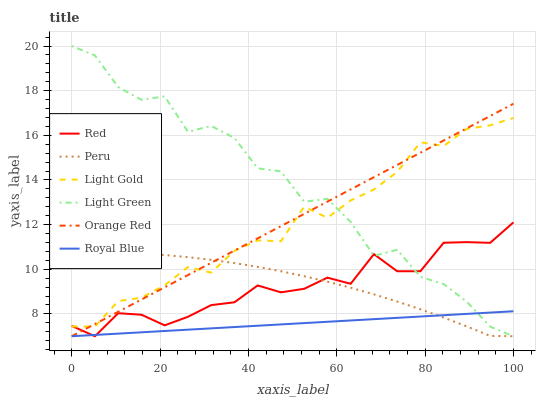Does Royal Blue have the minimum area under the curve?
Answer yes or no. Yes. Does Light Green have the maximum area under the curve?
Answer yes or no. Yes. Does Light Green have the minimum area under the curve?
Answer yes or no. No. Does Royal Blue have the maximum area under the curve?
Answer yes or no. No. Is Royal Blue the smoothest?
Answer yes or no. Yes. Is Light Green the roughest?
Answer yes or no. Yes. Is Light Green the smoothest?
Answer yes or no. No. Is Royal Blue the roughest?
Answer yes or no. No. Does Peru have the lowest value?
Answer yes or no. Yes. Does Light Gold have the lowest value?
Answer yes or no. No. Does Light Green have the highest value?
Answer yes or no. Yes. Does Royal Blue have the highest value?
Answer yes or no. No. Is Royal Blue less than Light Gold?
Answer yes or no. Yes. Is Light Gold greater than Royal Blue?
Answer yes or no. Yes. Does Peru intersect Light Gold?
Answer yes or no. Yes. Is Peru less than Light Gold?
Answer yes or no. No. Is Peru greater than Light Gold?
Answer yes or no. No. Does Royal Blue intersect Light Gold?
Answer yes or no. No. 